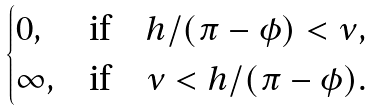<formula> <loc_0><loc_0><loc_500><loc_500>\begin{cases} 0 , & \text {if} \quad h / ( \pi - \phi ) < \nu , \\ \infty , & \text {if} \quad \nu < h / ( \pi - \phi ) . \end{cases}</formula> 